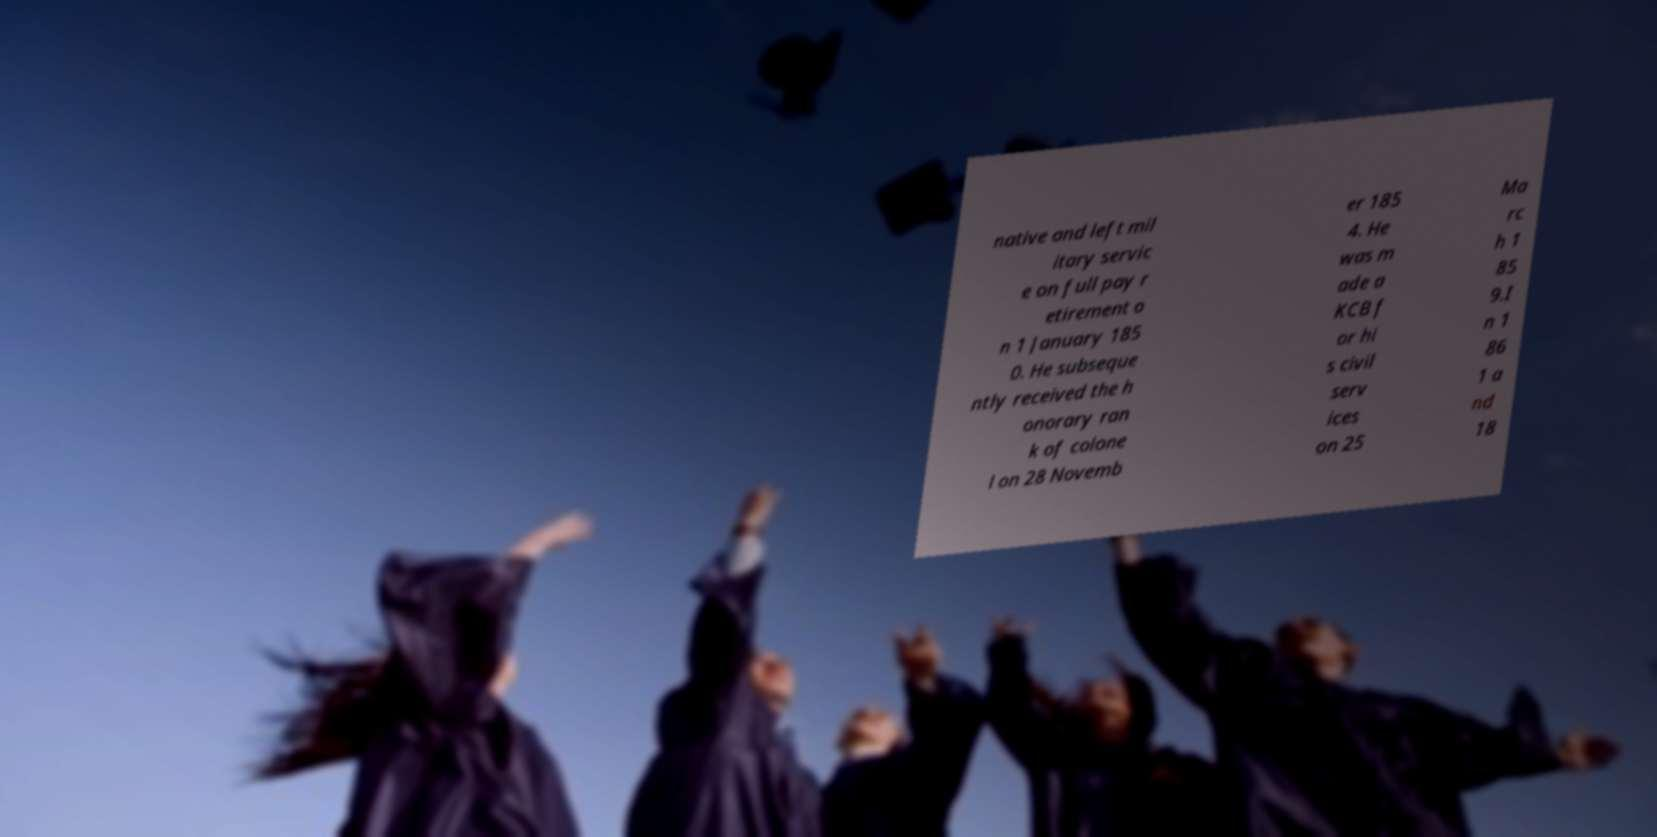What messages or text are displayed in this image? I need them in a readable, typed format. native and left mil itary servic e on full pay r etirement o n 1 January 185 0. He subseque ntly received the h onorary ran k of colone l on 28 Novemb er 185 4. He was m ade a KCB f or hi s civil serv ices on 25 Ma rc h 1 85 9.I n 1 86 1 a nd 18 